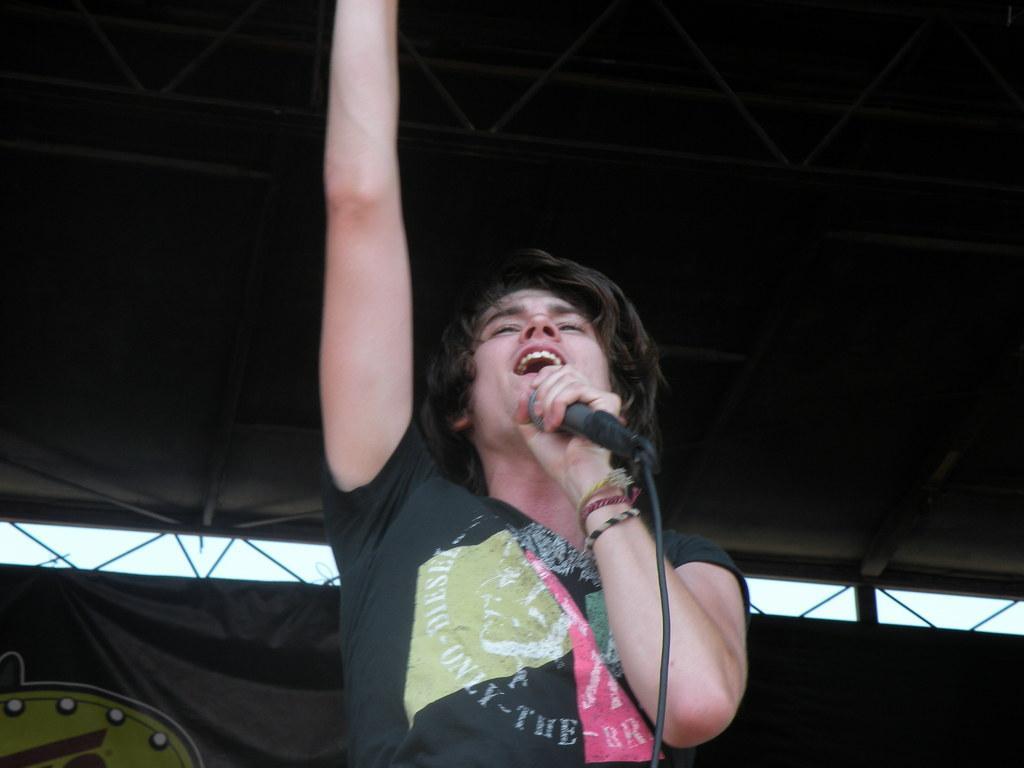Describe this image in one or two sentences. In the center of this picture we can see a person wearing black color t-shirt, holding a microphone and seems to be singing. In the background we can see the curtain, metal rods and the roof. 